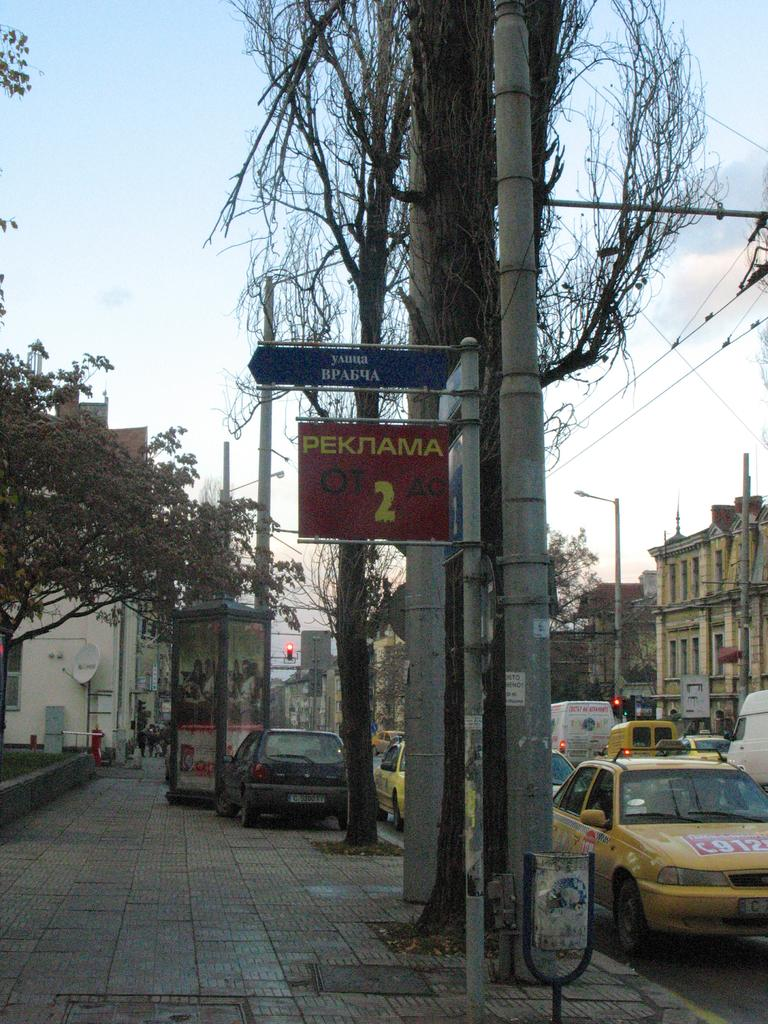<image>
Share a concise interpretation of the image provided. a red sign with the yellow number 2 on it 